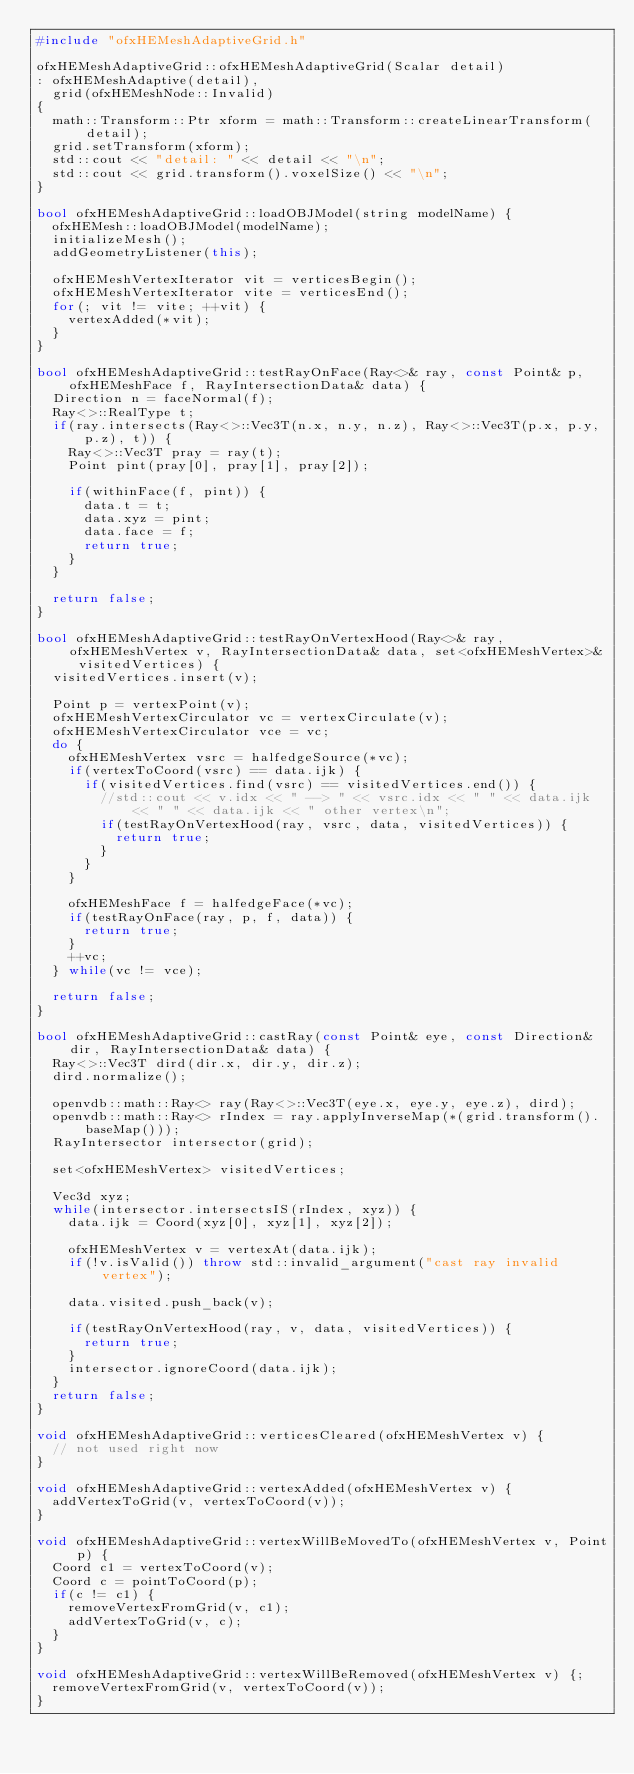Convert code to text. <code><loc_0><loc_0><loc_500><loc_500><_C++_>#include "ofxHEMeshAdaptiveGrid.h"

ofxHEMeshAdaptiveGrid::ofxHEMeshAdaptiveGrid(Scalar detail)
:	ofxHEMeshAdaptive(detail),
	grid(ofxHEMeshNode::Invalid)
{
	math::Transform::Ptr xform = math::Transform::createLinearTransform(detail);
	grid.setTransform(xform);
	std::cout << "detail: " << detail << "\n";
	std::cout << grid.transform().voxelSize() << "\n";
}

bool ofxHEMeshAdaptiveGrid::loadOBJModel(string modelName) {
	ofxHEMesh::loadOBJModel(modelName);
	initializeMesh();
	addGeometryListener(this);
	
	ofxHEMeshVertexIterator vit = verticesBegin();
	ofxHEMeshVertexIterator vite = verticesEnd();
	for(; vit != vite; ++vit) {
		vertexAdded(*vit);
	}
}

bool ofxHEMeshAdaptiveGrid::testRayOnFace(Ray<>& ray, const Point& p, ofxHEMeshFace f, RayIntersectionData& data) {
	Direction n = faceNormal(f);
	Ray<>::RealType t;
	if(ray.intersects(Ray<>::Vec3T(n.x, n.y, n.z), Ray<>::Vec3T(p.x, p.y, p.z), t)) {
		Ray<>::Vec3T pray = ray(t);
		Point pint(pray[0], pray[1], pray[2]);

		if(withinFace(f, pint)) {
			data.t = t;
			data.xyz = pint;
			data.face = f;
			return true;
		}
	}
	
	return false;
}

bool ofxHEMeshAdaptiveGrid::testRayOnVertexHood(Ray<>& ray, ofxHEMeshVertex v, RayIntersectionData& data, set<ofxHEMeshVertex>& visitedVertices) {
	visitedVertices.insert(v);

	Point p = vertexPoint(v);
	ofxHEMeshVertexCirculator vc = vertexCirculate(v);
	ofxHEMeshVertexCirculator vce = vc;
	do {
		ofxHEMeshVertex vsrc = halfedgeSource(*vc);
		if(vertexToCoord(vsrc) == data.ijk) {
			if(visitedVertices.find(vsrc) == visitedVertices.end()) {
				//std::cout << v.idx << " --> " << vsrc.idx << " " << data.ijk << " " << data.ijk << " other vertex\n";
				if(testRayOnVertexHood(ray, vsrc, data, visitedVertices)) {
					return true;
				}
			}
		}
	
		ofxHEMeshFace f = halfedgeFace(*vc);
		if(testRayOnFace(ray, p, f, data)) {
			return true;
		}
		++vc;
	} while(vc != vce);
	
	return false;
}

bool ofxHEMeshAdaptiveGrid::castRay(const Point& eye, const Direction& dir, RayIntersectionData& data) {
	Ray<>::Vec3T dird(dir.x, dir.y, dir.z);
	dird.normalize();
	
	openvdb::math::Ray<> ray(Ray<>::Vec3T(eye.x, eye.y, eye.z), dird);
	openvdb::math::Ray<> rIndex = ray.applyInverseMap(*(grid.transform().baseMap()));
	RayIntersector intersector(grid);
	
	set<ofxHEMeshVertex> visitedVertices;
	
	Vec3d xyz;
	while(intersector.intersectsIS(rIndex, xyz)) {
		data.ijk = Coord(xyz[0], xyz[1], xyz[2]);
	
		ofxHEMeshVertex v = vertexAt(data.ijk);
		if(!v.isValid()) throw std::invalid_argument("cast ray invalid vertex");
		
		data.visited.push_back(v);
		
		if(testRayOnVertexHood(ray, v, data, visitedVertices)) {
			return true;
		}
		intersector.ignoreCoord(data.ijk);
	}
	return false;
}

void ofxHEMeshAdaptiveGrid::verticesCleared(ofxHEMeshVertex v) {
	// not used right now
}

void ofxHEMeshAdaptiveGrid::vertexAdded(ofxHEMeshVertex v) {
	addVertexToGrid(v, vertexToCoord(v));
}

void ofxHEMeshAdaptiveGrid::vertexWillBeMovedTo(ofxHEMeshVertex v, Point p) {
	Coord c1 = vertexToCoord(v);
	Coord c = pointToCoord(p);
	if(c != c1) {
		removeVertexFromGrid(v, c1);
		addVertexToGrid(v, c);
	}
}

void ofxHEMeshAdaptiveGrid::vertexWillBeRemoved(ofxHEMeshVertex v) {;
	removeVertexFromGrid(v, vertexToCoord(v));
}
</code> 